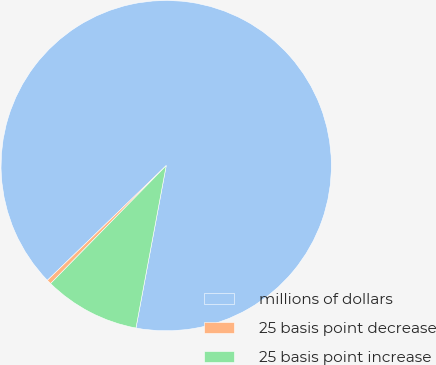Convert chart to OTSL. <chart><loc_0><loc_0><loc_500><loc_500><pie_chart><fcel>millions of dollars<fcel>25 basis point decrease<fcel>25 basis point increase<nl><fcel>90.14%<fcel>0.44%<fcel>9.41%<nl></chart> 